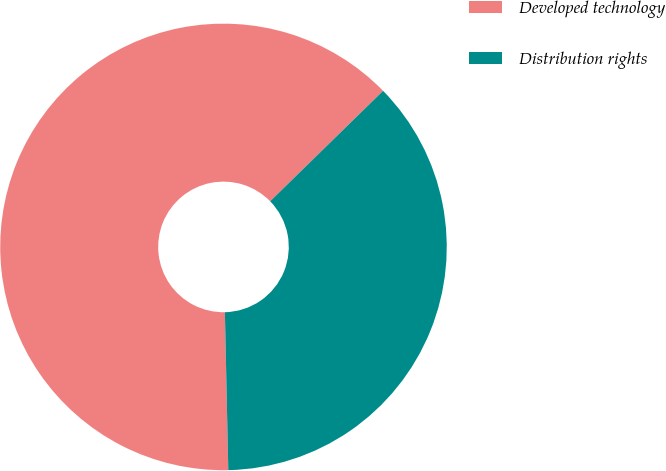Convert chart. <chart><loc_0><loc_0><loc_500><loc_500><pie_chart><fcel>Developed technology<fcel>Distribution rights<nl><fcel>63.02%<fcel>36.98%<nl></chart> 